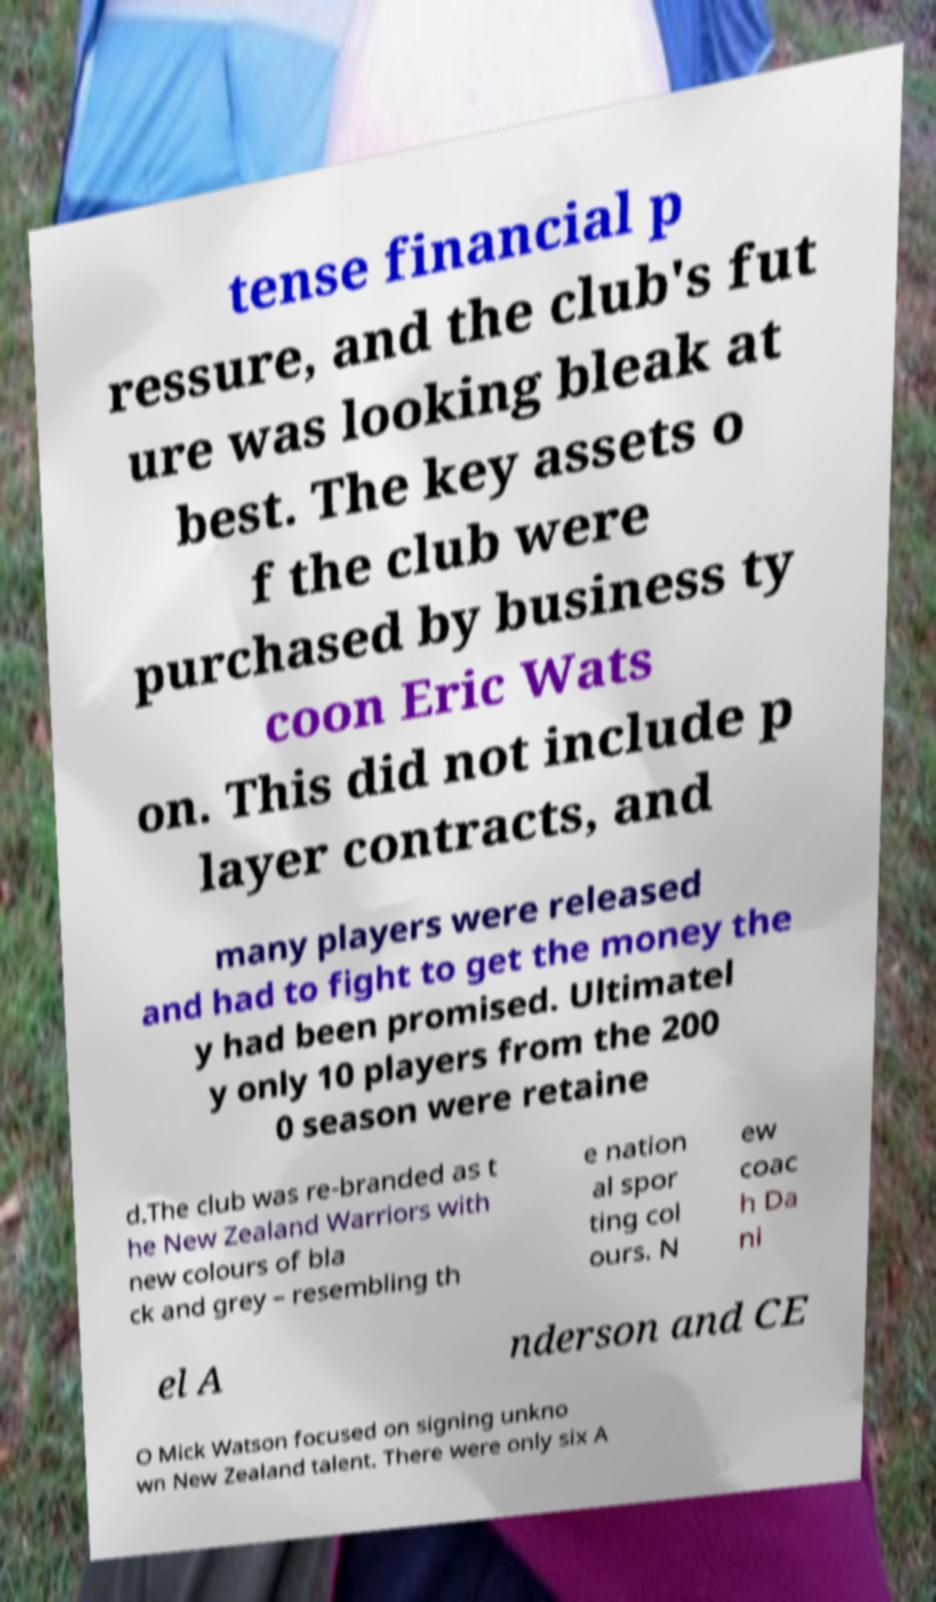Could you extract and type out the text from this image? tense financial p ressure, and the club's fut ure was looking bleak at best. The key assets o f the club were purchased by business ty coon Eric Wats on. This did not include p layer contracts, and many players were released and had to fight to get the money the y had been promised. Ultimatel y only 10 players from the 200 0 season were retaine d.The club was re-branded as t he New Zealand Warriors with new colours of bla ck and grey – resembling th e nation al spor ting col ours. N ew coac h Da ni el A nderson and CE O Mick Watson focused on signing unkno wn New Zealand talent. There were only six A 